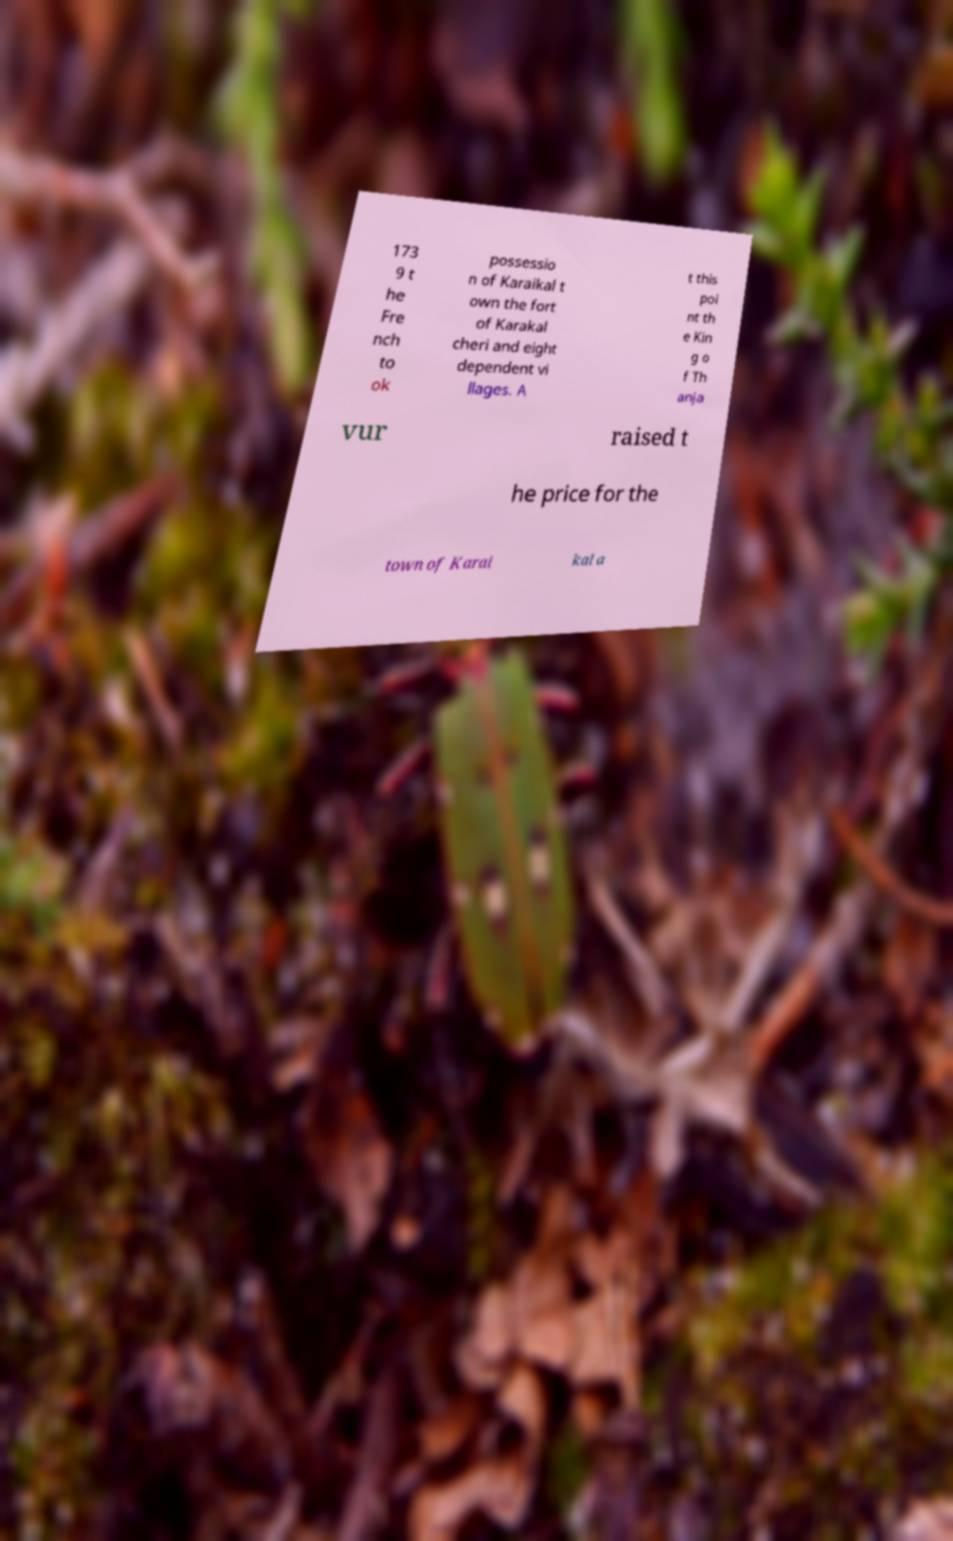I need the written content from this picture converted into text. Can you do that? 173 9 t he Fre nch to ok possessio n of Karaikal t own the fort of Karakal cheri and eight dependent vi llages. A t this poi nt th e Kin g o f Th anja vur raised t he price for the town of Karai kal a 